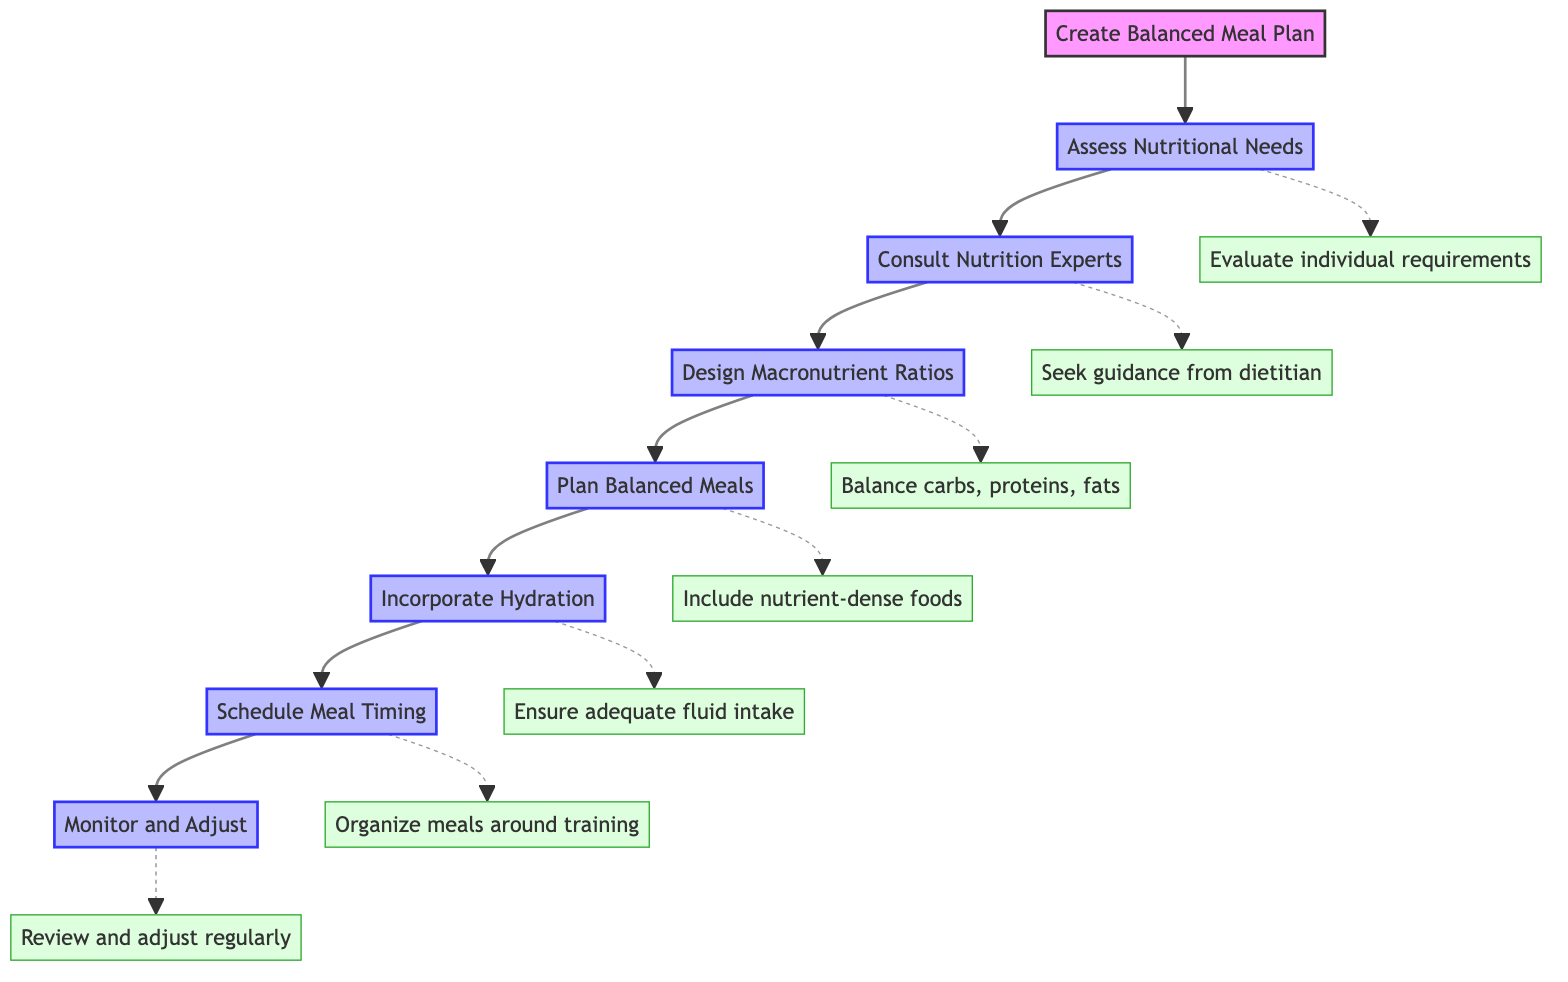What is the first step in creating a balanced meal plan? The diagram indicates that the first step is to "Assess Nutritional Needs." This is the first node connected directly to the main goal of creating a balanced meal plan.
Answer: Assess Nutritional Needs How many steps are there in total for meal planning? By counting the nodes in the diagram, we see there are seven steps listed from "Assess Nutritional Needs" to "Monitor and Adjust."
Answer: Seven What step follows after "Consult Nutrition Experts"? The diagram shows a direct connection from "Consult Nutrition Experts" to "Design Macronutrient Ratios." This indicates the sequential flow of the steps.
Answer: Design Macronutrient Ratios What is emphasized under "Incorporate Hydration"? The details connected to "Incorporate Hydration" state that one should "Ensure adequate fluid intake," which emphasizes the importance of hydration.
Answer: Ensure adequate fluid intake What does the final step instruct regarding the meal plan? The last step "Monitor and Adjust" indicates to "Review and adjust regularly," suggesting ongoing evaluation of the meal plan.
Answer: Review and adjust regularly How does the step "Plan Balanced Meals" contribute to the meal plan? The step includes the instruction to "Include nutrient-dense foods," which is essential for ensuring the meals are balanced and supportive of performance.
Answer: Include nutrient-dense foods Which two steps focus on the scheduling aspect of meals? The steps "Schedule Meal Timing" and "Plan Balanced Meals" both relate to the organization of eating times and meal composition for optimal performance.
Answer: Schedule Meal Timing, Plan Balanced Meals What action is suggested after evaluating nutritional needs? After "Assess Nutritional Needs," the next action suggested is to "Consult Nutrition Experts," demonstrating the sequential guidance for meal planning.
Answer: Consult Nutrition Experts What is one specific dietary requirement to consider? The first step details the need to "Evaluate individual requirements," indicating that personal factors like age and activity level must be taken into account.
Answer: Evaluate individual requirements 